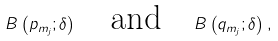<formula> <loc_0><loc_0><loc_500><loc_500>B \left ( p _ { m _ { j } } ; \delta \right ) \quad \text {and} \quad B \left ( q _ { m _ { j } } ; \delta \right ) ,</formula> 